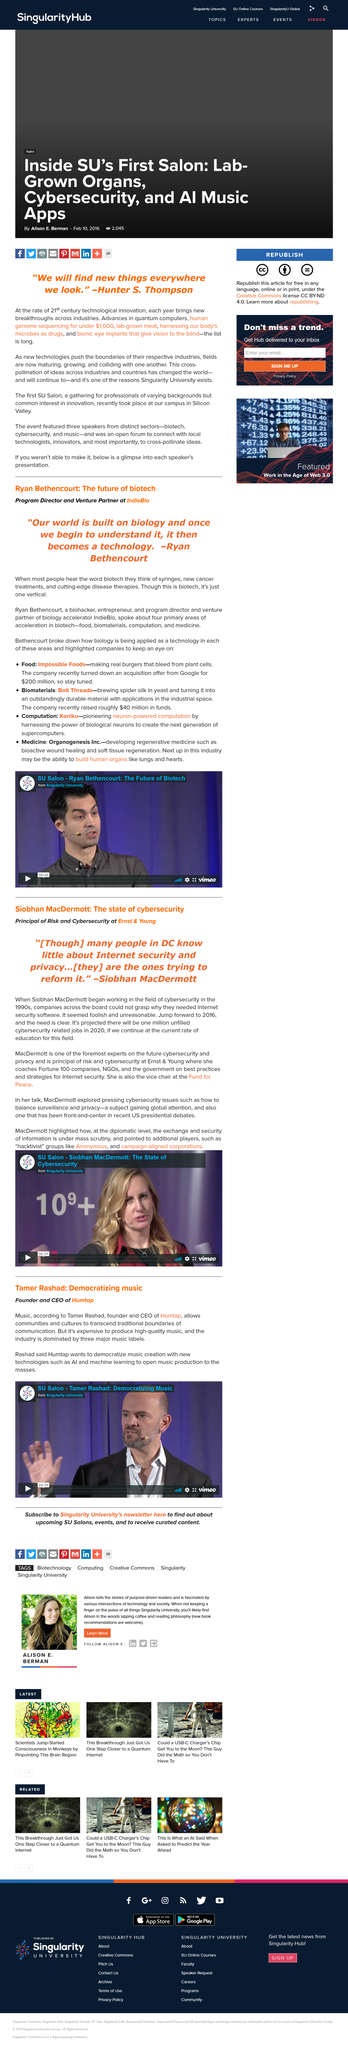Indicate a few pertinent items in this graphic. Tamer Rashad is the CEO of Humtap. Hunter S. Thompson famously stated, 'We will find new things everywhere we look.' New breakthroughs are being made in various industries each year, and there is evidence of cross-pollination between these industries. The Singularity University's Salon is located in Silicon Valley. The video on the man who aims to democratize music creation with technologies like AI and machine learning originated from Singularity University. 